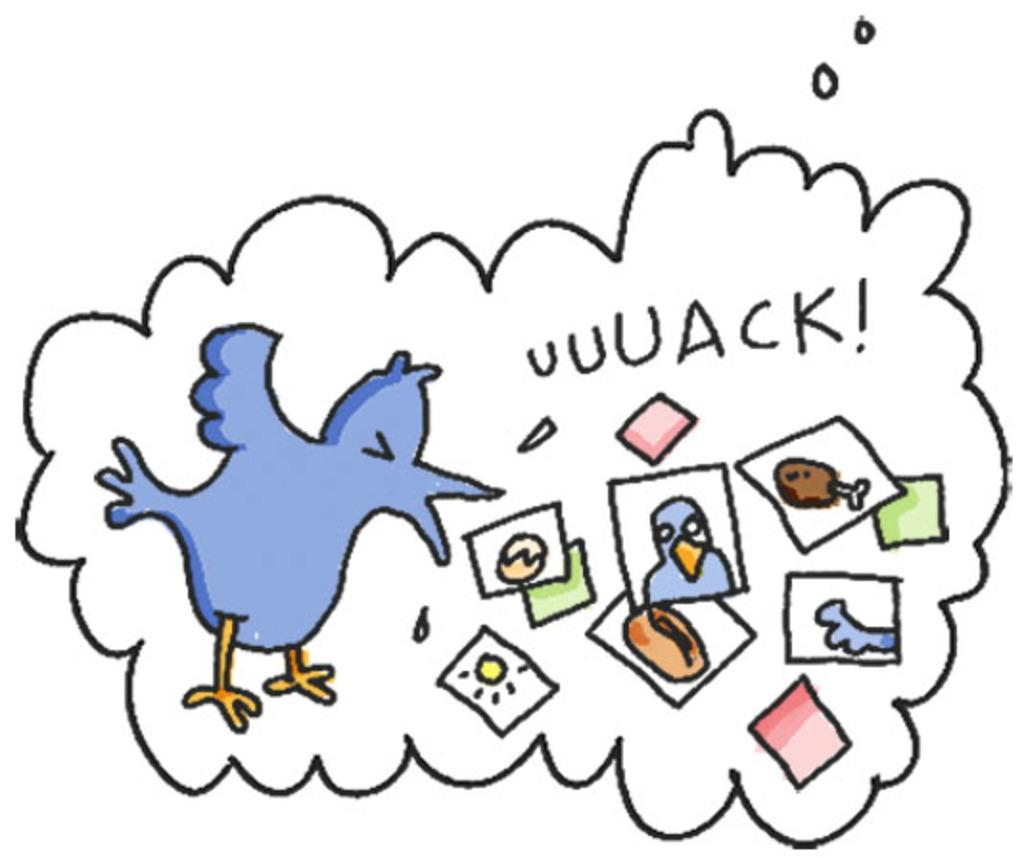What is depicted in the paintings in the image? There are paintings of two birds in the image. What else can be seen in the image besides the paintings? There is text in the image. Can you describe the color scheme of the image? There are colors present in the image. What type of bucket is used by the governor during recess in the image? There is no bucket, governor, or recess present in the image. 